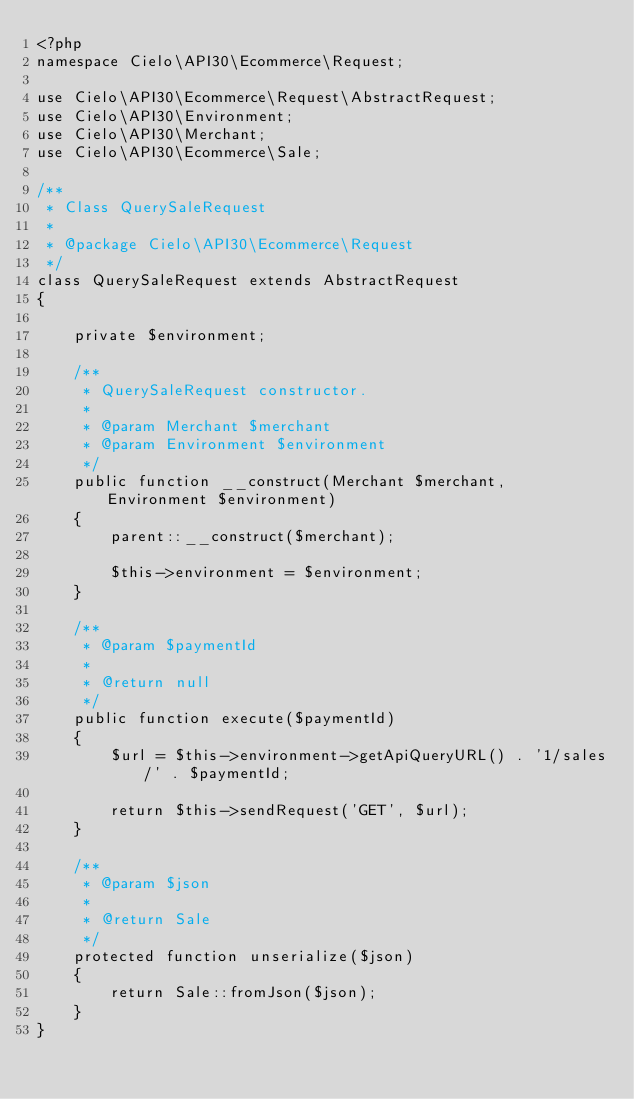Convert code to text. <code><loc_0><loc_0><loc_500><loc_500><_PHP_><?php
namespace Cielo\API30\Ecommerce\Request;

use Cielo\API30\Ecommerce\Request\AbstractRequest;
use Cielo\API30\Environment;
use Cielo\API30\Merchant;
use Cielo\API30\Ecommerce\Sale;

/**
 * Class QuerySaleRequest
 *
 * @package Cielo\API30\Ecommerce\Request
 */
class QuerySaleRequest extends AbstractRequest
{

    private $environment;

    /**
     * QuerySaleRequest constructor.
     *
     * @param Merchant $merchant
     * @param Environment $environment
     */
    public function __construct(Merchant $merchant, Environment $environment)
    {
        parent::__construct($merchant);

        $this->environment = $environment;
    }

    /**
     * @param $paymentId
     *
     * @return null
     */
    public function execute($paymentId)
    {
        $url = $this->environment->getApiQueryURL() . '1/sales/' . $paymentId;

        return $this->sendRequest('GET', $url);
    }

    /**
     * @param $json
     *
     * @return Sale
     */
    protected function unserialize($json)
    {
        return Sale::fromJson($json);
    }
}
</code> 